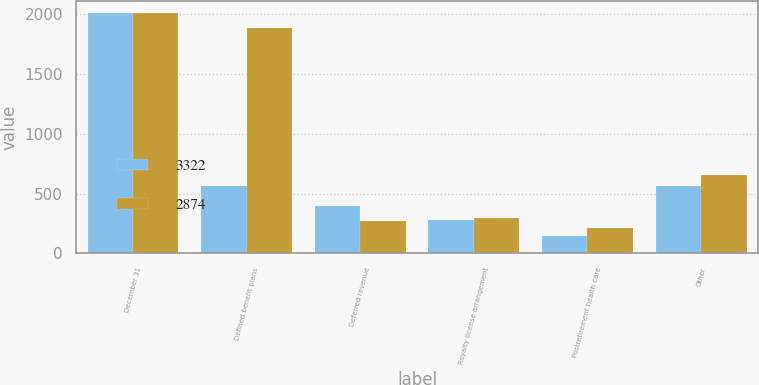Convert chart to OTSL. <chart><loc_0><loc_0><loc_500><loc_500><stacked_bar_chart><ecel><fcel>December 31<fcel>Defined benefit plans<fcel>Deferred revenue<fcel>Royalty license arrangement<fcel>Postretirement health care<fcel>Other<nl><fcel>3322<fcel>2007<fcel>562<fcel>393<fcel>282<fcel>144<fcel>560<nl><fcel>2874<fcel>2006<fcel>1882<fcel>273<fcel>300<fcel>214<fcel>653<nl></chart> 